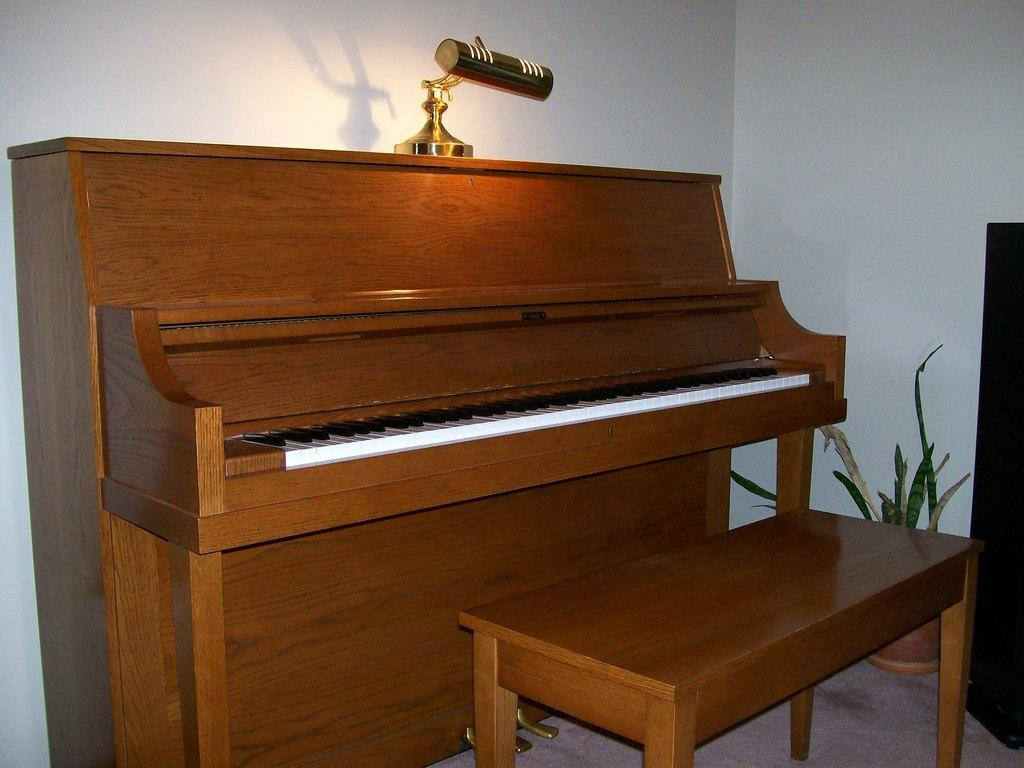What type of furniture is in the image? There is a piano table in the image. What is placed in front of the piano table? There is a bench in front of the table. What is on top of the piano table? There is a lamp on the table. Where can a plant be found in the image? There is a pot with a plant in the right side corner of the image. How many volleyballs are visible on the piano table in the image? There are no volleyballs visible on the piano table in the image. What type of rings are being worn by the plant in the image? There are no rings present in the image, as it features a pot with a plant and not a person wearing rings. 